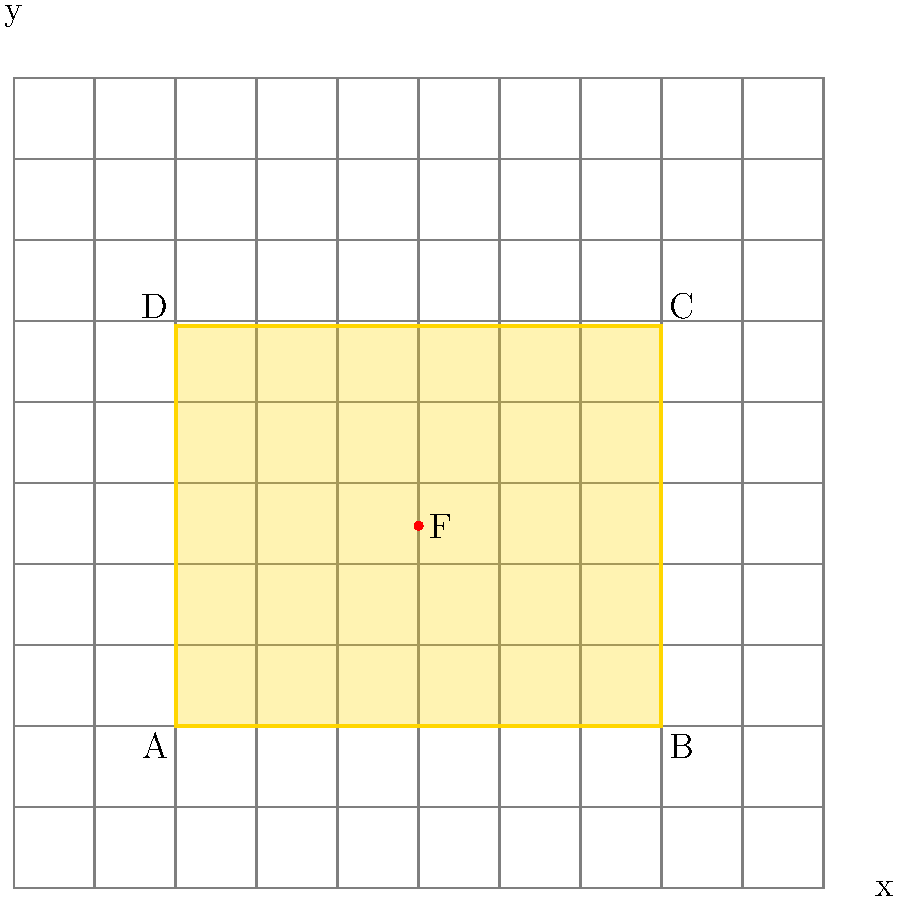In the composition analysis of a painting using a grid coordinate system, a golden rectangle ABCD is identified with its lower-left corner at (2,2) and upper-right corner at (8,6.944). If the focal point F of the composition is located at the intersection of the rectangle's diagonals, what are its coordinates? To find the coordinates of the focal point F, we need to follow these steps:

1. Identify the coordinates of the rectangle's corners:
   A(2,2), B(8,2), C(8,6.944), D(2,6.944)

2. The focal point F is at the intersection of the diagonals AC and BD.

3. To find F's coordinates, we can use the midpoint formula, as the intersection of diagonals in a rectangle is always at their midpoint:

   $F_x = \frac{A_x + C_x}{2} = \frac{2 + 8}{2} = 5$

   $F_y = \frac{A_y + C_y}{2} = \frac{2 + 6.944}{2} = 4.472$

4. Therefore, the coordinates of the focal point F are (5, 4.472).

Note: The golden rectangle has a width-to-height ratio of approximately 1:1.618 (the golden ratio), which is why the height is 4.944 units (6.944 - 2) for a width of 6 units (8 - 2).
Answer: (5, 4.472) 